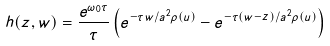<formula> <loc_0><loc_0><loc_500><loc_500>h ( z , w ) = \frac { e ^ { \omega _ { 0 } \tau } } { \tau } \left ( e ^ { - \tau w / a ^ { 2 } \rho ( u ) } - e ^ { - \tau ( w - z ) / a ^ { 2 } \rho ( u ) } \right )</formula> 